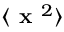<formula> <loc_0><loc_0><loc_500><loc_500>\langle x ^ { 2 } \rangle</formula> 